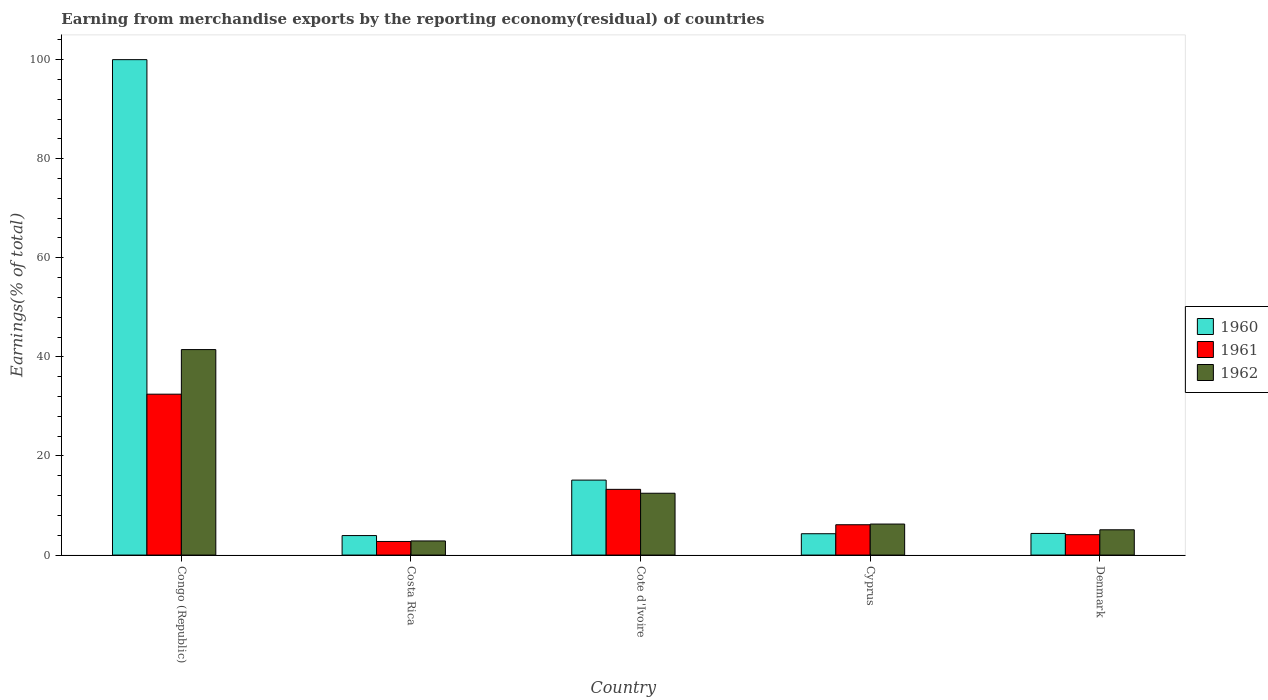How many bars are there on the 3rd tick from the left?
Give a very brief answer. 3. How many bars are there on the 1st tick from the right?
Offer a very short reply. 3. In how many cases, is the number of bars for a given country not equal to the number of legend labels?
Provide a short and direct response. 0. What is the percentage of amount earned from merchandise exports in 1960 in Denmark?
Keep it short and to the point. 4.36. Across all countries, what is the minimum percentage of amount earned from merchandise exports in 1961?
Provide a succinct answer. 2.75. In which country was the percentage of amount earned from merchandise exports in 1960 maximum?
Provide a succinct answer. Congo (Republic). In which country was the percentage of amount earned from merchandise exports in 1960 minimum?
Offer a terse response. Costa Rica. What is the total percentage of amount earned from merchandise exports in 1960 in the graph?
Provide a short and direct response. 127.74. What is the difference between the percentage of amount earned from merchandise exports in 1961 in Costa Rica and that in Cyprus?
Offer a very short reply. -3.38. What is the difference between the percentage of amount earned from merchandise exports in 1962 in Costa Rica and the percentage of amount earned from merchandise exports in 1961 in Congo (Republic)?
Offer a very short reply. -29.62. What is the average percentage of amount earned from merchandise exports in 1961 per country?
Offer a very short reply. 11.75. What is the difference between the percentage of amount earned from merchandise exports of/in 1961 and percentage of amount earned from merchandise exports of/in 1960 in Costa Rica?
Make the answer very short. -1.19. In how many countries, is the percentage of amount earned from merchandise exports in 1961 greater than 80 %?
Your answer should be very brief. 0. What is the ratio of the percentage of amount earned from merchandise exports in 1961 in Costa Rica to that in Cote d'Ivoire?
Your response must be concise. 0.21. Is the percentage of amount earned from merchandise exports in 1962 in Costa Rica less than that in Cote d'Ivoire?
Provide a short and direct response. Yes. What is the difference between the highest and the second highest percentage of amount earned from merchandise exports in 1960?
Give a very brief answer. 95.64. What is the difference between the highest and the lowest percentage of amount earned from merchandise exports in 1961?
Ensure brevity in your answer.  29.73. In how many countries, is the percentage of amount earned from merchandise exports in 1960 greater than the average percentage of amount earned from merchandise exports in 1960 taken over all countries?
Provide a succinct answer. 1. How many bars are there?
Offer a very short reply. 15. Are all the bars in the graph horizontal?
Provide a short and direct response. No. How many countries are there in the graph?
Offer a very short reply. 5. Are the values on the major ticks of Y-axis written in scientific E-notation?
Give a very brief answer. No. Does the graph contain grids?
Make the answer very short. No. How many legend labels are there?
Your answer should be compact. 3. How are the legend labels stacked?
Make the answer very short. Vertical. What is the title of the graph?
Your answer should be very brief. Earning from merchandise exports by the reporting economy(residual) of countries. Does "2015" appear as one of the legend labels in the graph?
Your response must be concise. No. What is the label or title of the X-axis?
Make the answer very short. Country. What is the label or title of the Y-axis?
Offer a very short reply. Earnings(% of total). What is the Earnings(% of total) in 1960 in Congo (Republic)?
Your response must be concise. 100. What is the Earnings(% of total) of 1961 in Congo (Republic)?
Offer a terse response. 32.47. What is the Earnings(% of total) of 1962 in Congo (Republic)?
Your answer should be compact. 41.48. What is the Earnings(% of total) in 1960 in Costa Rica?
Ensure brevity in your answer.  3.94. What is the Earnings(% of total) of 1961 in Costa Rica?
Your response must be concise. 2.75. What is the Earnings(% of total) in 1962 in Costa Rica?
Make the answer very short. 2.85. What is the Earnings(% of total) in 1960 in Cote d'Ivoire?
Make the answer very short. 15.13. What is the Earnings(% of total) in 1961 in Cote d'Ivoire?
Offer a terse response. 13.27. What is the Earnings(% of total) in 1962 in Cote d'Ivoire?
Give a very brief answer. 12.48. What is the Earnings(% of total) of 1960 in Cyprus?
Make the answer very short. 4.31. What is the Earnings(% of total) of 1961 in Cyprus?
Your answer should be very brief. 6.12. What is the Earnings(% of total) of 1962 in Cyprus?
Ensure brevity in your answer.  6.26. What is the Earnings(% of total) in 1960 in Denmark?
Your answer should be compact. 4.36. What is the Earnings(% of total) of 1961 in Denmark?
Your answer should be very brief. 4.12. What is the Earnings(% of total) in 1962 in Denmark?
Your answer should be compact. 5.1. Across all countries, what is the maximum Earnings(% of total) of 1960?
Offer a terse response. 100. Across all countries, what is the maximum Earnings(% of total) of 1961?
Offer a very short reply. 32.47. Across all countries, what is the maximum Earnings(% of total) of 1962?
Provide a succinct answer. 41.48. Across all countries, what is the minimum Earnings(% of total) in 1960?
Ensure brevity in your answer.  3.94. Across all countries, what is the minimum Earnings(% of total) of 1961?
Your response must be concise. 2.75. Across all countries, what is the minimum Earnings(% of total) of 1962?
Offer a very short reply. 2.85. What is the total Earnings(% of total) in 1960 in the graph?
Provide a succinct answer. 127.74. What is the total Earnings(% of total) in 1961 in the graph?
Provide a succinct answer. 58.73. What is the total Earnings(% of total) of 1962 in the graph?
Offer a very short reply. 68.17. What is the difference between the Earnings(% of total) in 1960 in Congo (Republic) and that in Costa Rica?
Give a very brief answer. 96.06. What is the difference between the Earnings(% of total) of 1961 in Congo (Republic) and that in Costa Rica?
Your answer should be compact. 29.73. What is the difference between the Earnings(% of total) of 1962 in Congo (Republic) and that in Costa Rica?
Your answer should be very brief. 38.63. What is the difference between the Earnings(% of total) in 1960 in Congo (Republic) and that in Cote d'Ivoire?
Offer a very short reply. 84.87. What is the difference between the Earnings(% of total) in 1961 in Congo (Republic) and that in Cote d'Ivoire?
Your response must be concise. 19.21. What is the difference between the Earnings(% of total) in 1962 in Congo (Republic) and that in Cote d'Ivoire?
Ensure brevity in your answer.  29. What is the difference between the Earnings(% of total) in 1960 in Congo (Republic) and that in Cyprus?
Provide a succinct answer. 95.69. What is the difference between the Earnings(% of total) in 1961 in Congo (Republic) and that in Cyprus?
Your answer should be compact. 26.35. What is the difference between the Earnings(% of total) of 1962 in Congo (Republic) and that in Cyprus?
Your answer should be compact. 35.22. What is the difference between the Earnings(% of total) in 1960 in Congo (Republic) and that in Denmark?
Provide a short and direct response. 95.64. What is the difference between the Earnings(% of total) in 1961 in Congo (Republic) and that in Denmark?
Offer a terse response. 28.36. What is the difference between the Earnings(% of total) of 1962 in Congo (Republic) and that in Denmark?
Your answer should be compact. 36.37. What is the difference between the Earnings(% of total) in 1960 in Costa Rica and that in Cote d'Ivoire?
Offer a very short reply. -11.2. What is the difference between the Earnings(% of total) of 1961 in Costa Rica and that in Cote d'Ivoire?
Provide a succinct answer. -10.52. What is the difference between the Earnings(% of total) in 1962 in Costa Rica and that in Cote d'Ivoire?
Keep it short and to the point. -9.63. What is the difference between the Earnings(% of total) in 1960 in Costa Rica and that in Cyprus?
Make the answer very short. -0.37. What is the difference between the Earnings(% of total) in 1961 in Costa Rica and that in Cyprus?
Keep it short and to the point. -3.38. What is the difference between the Earnings(% of total) in 1962 in Costa Rica and that in Cyprus?
Make the answer very short. -3.41. What is the difference between the Earnings(% of total) of 1960 in Costa Rica and that in Denmark?
Ensure brevity in your answer.  -0.43. What is the difference between the Earnings(% of total) of 1961 in Costa Rica and that in Denmark?
Ensure brevity in your answer.  -1.37. What is the difference between the Earnings(% of total) in 1962 in Costa Rica and that in Denmark?
Offer a terse response. -2.25. What is the difference between the Earnings(% of total) in 1960 in Cote d'Ivoire and that in Cyprus?
Give a very brief answer. 10.83. What is the difference between the Earnings(% of total) in 1961 in Cote d'Ivoire and that in Cyprus?
Offer a terse response. 7.14. What is the difference between the Earnings(% of total) in 1962 in Cote d'Ivoire and that in Cyprus?
Your answer should be compact. 6.22. What is the difference between the Earnings(% of total) of 1960 in Cote d'Ivoire and that in Denmark?
Your response must be concise. 10.77. What is the difference between the Earnings(% of total) in 1961 in Cote d'Ivoire and that in Denmark?
Your answer should be compact. 9.15. What is the difference between the Earnings(% of total) of 1962 in Cote d'Ivoire and that in Denmark?
Your response must be concise. 7.38. What is the difference between the Earnings(% of total) of 1960 in Cyprus and that in Denmark?
Offer a terse response. -0.06. What is the difference between the Earnings(% of total) of 1961 in Cyprus and that in Denmark?
Provide a short and direct response. 2. What is the difference between the Earnings(% of total) in 1962 in Cyprus and that in Denmark?
Ensure brevity in your answer.  1.16. What is the difference between the Earnings(% of total) of 1960 in Congo (Republic) and the Earnings(% of total) of 1961 in Costa Rica?
Make the answer very short. 97.25. What is the difference between the Earnings(% of total) in 1960 in Congo (Republic) and the Earnings(% of total) in 1962 in Costa Rica?
Ensure brevity in your answer.  97.15. What is the difference between the Earnings(% of total) in 1961 in Congo (Republic) and the Earnings(% of total) in 1962 in Costa Rica?
Offer a terse response. 29.62. What is the difference between the Earnings(% of total) in 1960 in Congo (Republic) and the Earnings(% of total) in 1961 in Cote d'Ivoire?
Give a very brief answer. 86.73. What is the difference between the Earnings(% of total) in 1960 in Congo (Republic) and the Earnings(% of total) in 1962 in Cote d'Ivoire?
Give a very brief answer. 87.52. What is the difference between the Earnings(% of total) in 1961 in Congo (Republic) and the Earnings(% of total) in 1962 in Cote d'Ivoire?
Provide a short and direct response. 19.99. What is the difference between the Earnings(% of total) of 1960 in Congo (Republic) and the Earnings(% of total) of 1961 in Cyprus?
Give a very brief answer. 93.88. What is the difference between the Earnings(% of total) of 1960 in Congo (Republic) and the Earnings(% of total) of 1962 in Cyprus?
Your response must be concise. 93.74. What is the difference between the Earnings(% of total) in 1961 in Congo (Republic) and the Earnings(% of total) in 1962 in Cyprus?
Keep it short and to the point. 26.21. What is the difference between the Earnings(% of total) in 1960 in Congo (Republic) and the Earnings(% of total) in 1961 in Denmark?
Your response must be concise. 95.88. What is the difference between the Earnings(% of total) in 1960 in Congo (Republic) and the Earnings(% of total) in 1962 in Denmark?
Offer a terse response. 94.9. What is the difference between the Earnings(% of total) of 1961 in Congo (Republic) and the Earnings(% of total) of 1962 in Denmark?
Provide a succinct answer. 27.37. What is the difference between the Earnings(% of total) in 1960 in Costa Rica and the Earnings(% of total) in 1961 in Cote d'Ivoire?
Your answer should be very brief. -9.33. What is the difference between the Earnings(% of total) in 1960 in Costa Rica and the Earnings(% of total) in 1962 in Cote d'Ivoire?
Keep it short and to the point. -8.55. What is the difference between the Earnings(% of total) in 1961 in Costa Rica and the Earnings(% of total) in 1962 in Cote d'Ivoire?
Ensure brevity in your answer.  -9.73. What is the difference between the Earnings(% of total) in 1960 in Costa Rica and the Earnings(% of total) in 1961 in Cyprus?
Provide a succinct answer. -2.19. What is the difference between the Earnings(% of total) of 1960 in Costa Rica and the Earnings(% of total) of 1962 in Cyprus?
Provide a short and direct response. -2.33. What is the difference between the Earnings(% of total) in 1961 in Costa Rica and the Earnings(% of total) in 1962 in Cyprus?
Provide a short and direct response. -3.51. What is the difference between the Earnings(% of total) of 1960 in Costa Rica and the Earnings(% of total) of 1961 in Denmark?
Offer a very short reply. -0.18. What is the difference between the Earnings(% of total) in 1960 in Costa Rica and the Earnings(% of total) in 1962 in Denmark?
Keep it short and to the point. -1.17. What is the difference between the Earnings(% of total) in 1961 in Costa Rica and the Earnings(% of total) in 1962 in Denmark?
Provide a short and direct response. -2.36. What is the difference between the Earnings(% of total) of 1960 in Cote d'Ivoire and the Earnings(% of total) of 1961 in Cyprus?
Provide a short and direct response. 9.01. What is the difference between the Earnings(% of total) in 1960 in Cote d'Ivoire and the Earnings(% of total) in 1962 in Cyprus?
Make the answer very short. 8.87. What is the difference between the Earnings(% of total) in 1961 in Cote d'Ivoire and the Earnings(% of total) in 1962 in Cyprus?
Ensure brevity in your answer.  7. What is the difference between the Earnings(% of total) in 1960 in Cote d'Ivoire and the Earnings(% of total) in 1961 in Denmark?
Keep it short and to the point. 11.01. What is the difference between the Earnings(% of total) in 1960 in Cote d'Ivoire and the Earnings(% of total) in 1962 in Denmark?
Ensure brevity in your answer.  10.03. What is the difference between the Earnings(% of total) of 1961 in Cote d'Ivoire and the Earnings(% of total) of 1962 in Denmark?
Offer a terse response. 8.16. What is the difference between the Earnings(% of total) in 1960 in Cyprus and the Earnings(% of total) in 1961 in Denmark?
Your answer should be compact. 0.19. What is the difference between the Earnings(% of total) of 1960 in Cyprus and the Earnings(% of total) of 1962 in Denmark?
Your answer should be very brief. -0.8. What is the difference between the Earnings(% of total) in 1961 in Cyprus and the Earnings(% of total) in 1962 in Denmark?
Your answer should be compact. 1.02. What is the average Earnings(% of total) of 1960 per country?
Give a very brief answer. 25.55. What is the average Earnings(% of total) in 1961 per country?
Your answer should be compact. 11.75. What is the average Earnings(% of total) of 1962 per country?
Offer a very short reply. 13.63. What is the difference between the Earnings(% of total) in 1960 and Earnings(% of total) in 1961 in Congo (Republic)?
Your answer should be compact. 67.53. What is the difference between the Earnings(% of total) in 1960 and Earnings(% of total) in 1962 in Congo (Republic)?
Offer a very short reply. 58.52. What is the difference between the Earnings(% of total) in 1961 and Earnings(% of total) in 1962 in Congo (Republic)?
Make the answer very short. -9. What is the difference between the Earnings(% of total) of 1960 and Earnings(% of total) of 1961 in Costa Rica?
Your answer should be very brief. 1.19. What is the difference between the Earnings(% of total) in 1960 and Earnings(% of total) in 1962 in Costa Rica?
Ensure brevity in your answer.  1.08. What is the difference between the Earnings(% of total) of 1961 and Earnings(% of total) of 1962 in Costa Rica?
Your answer should be very brief. -0.1. What is the difference between the Earnings(% of total) of 1960 and Earnings(% of total) of 1961 in Cote d'Ivoire?
Your answer should be very brief. 1.87. What is the difference between the Earnings(% of total) in 1960 and Earnings(% of total) in 1962 in Cote d'Ivoire?
Provide a short and direct response. 2.65. What is the difference between the Earnings(% of total) of 1961 and Earnings(% of total) of 1962 in Cote d'Ivoire?
Provide a succinct answer. 0.79. What is the difference between the Earnings(% of total) in 1960 and Earnings(% of total) in 1961 in Cyprus?
Ensure brevity in your answer.  -1.82. What is the difference between the Earnings(% of total) in 1960 and Earnings(% of total) in 1962 in Cyprus?
Provide a succinct answer. -1.95. What is the difference between the Earnings(% of total) in 1961 and Earnings(% of total) in 1962 in Cyprus?
Give a very brief answer. -0.14. What is the difference between the Earnings(% of total) of 1960 and Earnings(% of total) of 1961 in Denmark?
Provide a succinct answer. 0.25. What is the difference between the Earnings(% of total) in 1960 and Earnings(% of total) in 1962 in Denmark?
Ensure brevity in your answer.  -0.74. What is the difference between the Earnings(% of total) of 1961 and Earnings(% of total) of 1962 in Denmark?
Offer a terse response. -0.99. What is the ratio of the Earnings(% of total) in 1960 in Congo (Republic) to that in Costa Rica?
Ensure brevity in your answer.  25.41. What is the ratio of the Earnings(% of total) in 1961 in Congo (Republic) to that in Costa Rica?
Provide a succinct answer. 11.82. What is the ratio of the Earnings(% of total) in 1962 in Congo (Republic) to that in Costa Rica?
Keep it short and to the point. 14.55. What is the ratio of the Earnings(% of total) of 1960 in Congo (Republic) to that in Cote d'Ivoire?
Your answer should be compact. 6.61. What is the ratio of the Earnings(% of total) in 1961 in Congo (Republic) to that in Cote d'Ivoire?
Offer a very short reply. 2.45. What is the ratio of the Earnings(% of total) in 1962 in Congo (Republic) to that in Cote d'Ivoire?
Ensure brevity in your answer.  3.32. What is the ratio of the Earnings(% of total) in 1960 in Congo (Republic) to that in Cyprus?
Your response must be concise. 23.22. What is the ratio of the Earnings(% of total) in 1961 in Congo (Republic) to that in Cyprus?
Offer a very short reply. 5.3. What is the ratio of the Earnings(% of total) in 1962 in Congo (Republic) to that in Cyprus?
Your answer should be very brief. 6.62. What is the ratio of the Earnings(% of total) in 1960 in Congo (Republic) to that in Denmark?
Your answer should be very brief. 22.91. What is the ratio of the Earnings(% of total) of 1961 in Congo (Republic) to that in Denmark?
Your answer should be compact. 7.89. What is the ratio of the Earnings(% of total) of 1962 in Congo (Republic) to that in Denmark?
Your answer should be compact. 8.13. What is the ratio of the Earnings(% of total) of 1960 in Costa Rica to that in Cote d'Ivoire?
Make the answer very short. 0.26. What is the ratio of the Earnings(% of total) of 1961 in Costa Rica to that in Cote d'Ivoire?
Provide a succinct answer. 0.21. What is the ratio of the Earnings(% of total) of 1962 in Costa Rica to that in Cote d'Ivoire?
Give a very brief answer. 0.23. What is the ratio of the Earnings(% of total) in 1960 in Costa Rica to that in Cyprus?
Your answer should be very brief. 0.91. What is the ratio of the Earnings(% of total) in 1961 in Costa Rica to that in Cyprus?
Provide a succinct answer. 0.45. What is the ratio of the Earnings(% of total) of 1962 in Costa Rica to that in Cyprus?
Ensure brevity in your answer.  0.46. What is the ratio of the Earnings(% of total) of 1960 in Costa Rica to that in Denmark?
Give a very brief answer. 0.9. What is the ratio of the Earnings(% of total) in 1961 in Costa Rica to that in Denmark?
Your response must be concise. 0.67. What is the ratio of the Earnings(% of total) of 1962 in Costa Rica to that in Denmark?
Your answer should be very brief. 0.56. What is the ratio of the Earnings(% of total) of 1960 in Cote d'Ivoire to that in Cyprus?
Provide a short and direct response. 3.51. What is the ratio of the Earnings(% of total) of 1961 in Cote d'Ivoire to that in Cyprus?
Offer a very short reply. 2.17. What is the ratio of the Earnings(% of total) in 1962 in Cote d'Ivoire to that in Cyprus?
Your answer should be compact. 1.99. What is the ratio of the Earnings(% of total) of 1960 in Cote d'Ivoire to that in Denmark?
Ensure brevity in your answer.  3.47. What is the ratio of the Earnings(% of total) in 1961 in Cote d'Ivoire to that in Denmark?
Your response must be concise. 3.22. What is the ratio of the Earnings(% of total) of 1962 in Cote d'Ivoire to that in Denmark?
Offer a very short reply. 2.44. What is the ratio of the Earnings(% of total) in 1961 in Cyprus to that in Denmark?
Give a very brief answer. 1.49. What is the ratio of the Earnings(% of total) in 1962 in Cyprus to that in Denmark?
Make the answer very short. 1.23. What is the difference between the highest and the second highest Earnings(% of total) in 1960?
Ensure brevity in your answer.  84.87. What is the difference between the highest and the second highest Earnings(% of total) in 1961?
Provide a succinct answer. 19.21. What is the difference between the highest and the second highest Earnings(% of total) of 1962?
Provide a short and direct response. 29. What is the difference between the highest and the lowest Earnings(% of total) in 1960?
Your answer should be compact. 96.06. What is the difference between the highest and the lowest Earnings(% of total) of 1961?
Your response must be concise. 29.73. What is the difference between the highest and the lowest Earnings(% of total) in 1962?
Ensure brevity in your answer.  38.63. 